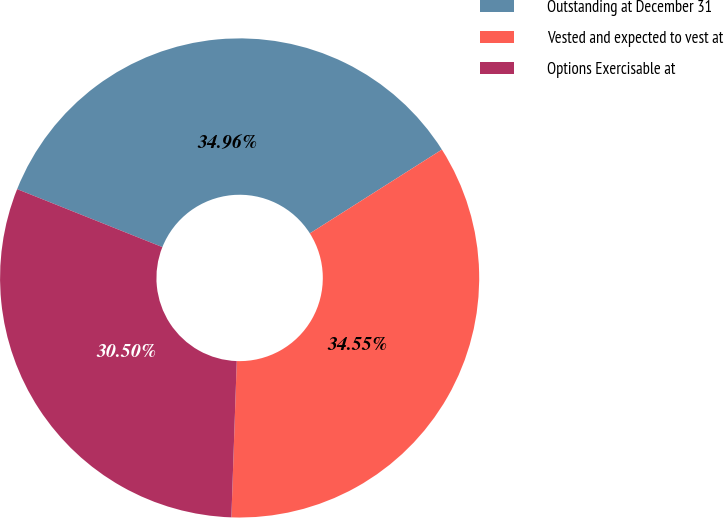<chart> <loc_0><loc_0><loc_500><loc_500><pie_chart><fcel>Outstanding at December 31<fcel>Vested and expected to vest at<fcel>Options Exercisable at<nl><fcel>34.96%<fcel>34.55%<fcel>30.5%<nl></chart> 